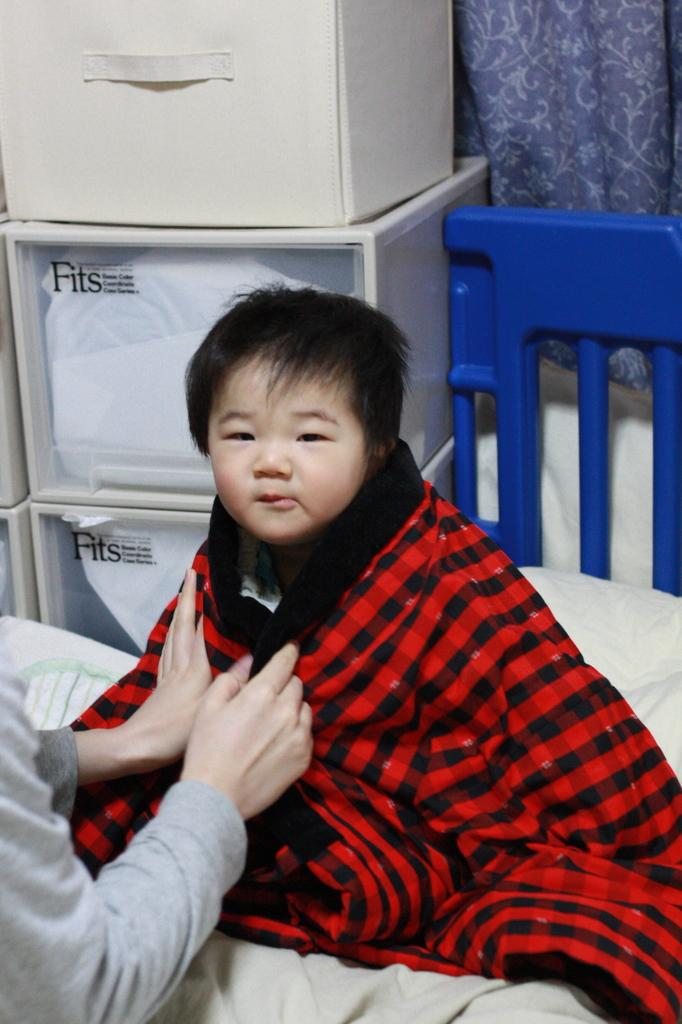Who is present in the image? There is a boy in the image. What is the boy doing in the image? The boy is on a bed. What object does the boy have in the image? The boy has a towel. Can you describe another person in the image? There is a person holding a towel in the image. What else can be seen in the image? There are boxes and a curtain in the image. What type of drug is being distributed by the person in the image? There is no drug present in the image, and no distribution is taking place. How much payment is required for the services provided in the image? There is no service being provided in the image, and no payment is mentioned or implied. 